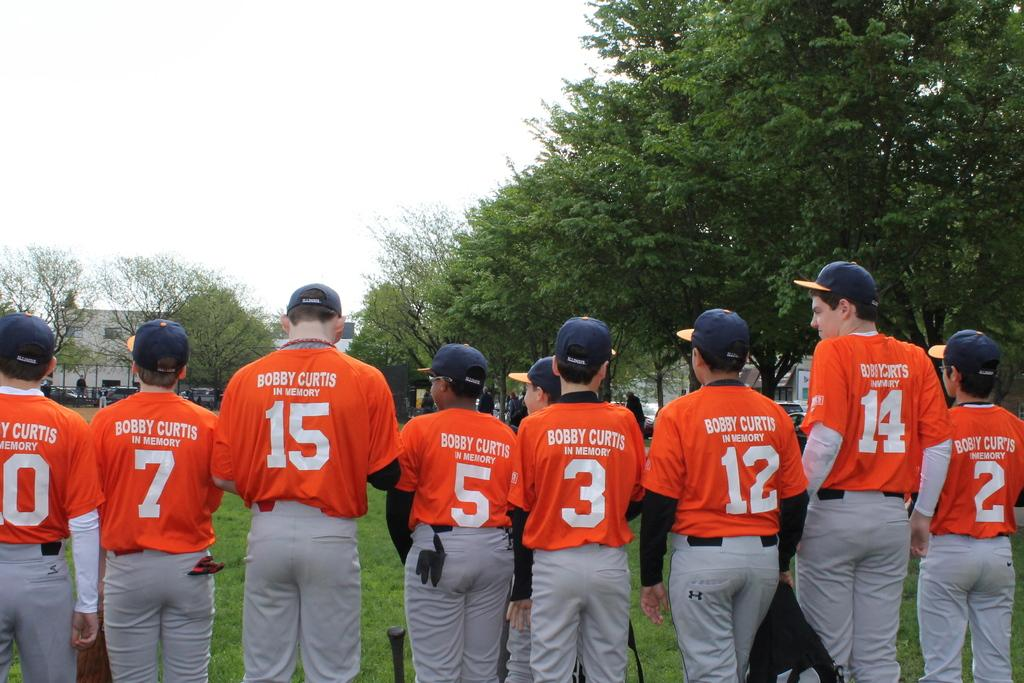<image>
Present a compact description of the photo's key features. Youth baseball team with Bobby Curtis in memory in white letters on the back of their orange uniform shirts. 